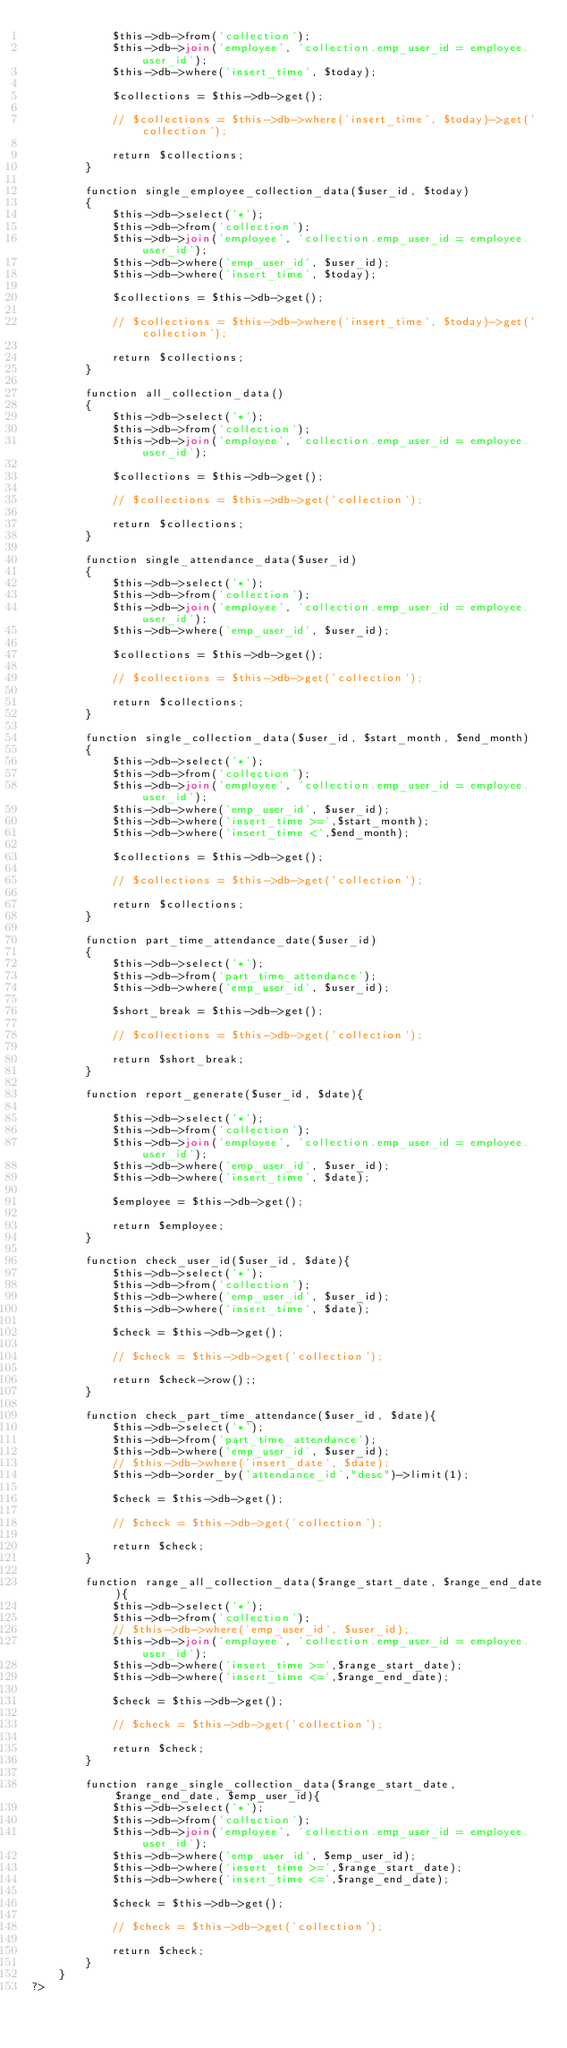<code> <loc_0><loc_0><loc_500><loc_500><_PHP_>			$this->db->from('collection');
			$this->db->join('employee', 'collection.emp_user_id = employee.user_id');
			$this->db->where('insert_time', $today);

			$collections = $this->db->get();

			// $collections = $this->db->where('insert_time', $today)->get('collection');

			return $collections;
		}

		function single_employee_collection_data($user_id, $today)
		{
			$this->db->select('*');
			$this->db->from('collection');
			$this->db->join('employee', 'collection.emp_user_id = employee.user_id');
			$this->db->where('emp_user_id', $user_id);
			$this->db->where('insert_time', $today);

			$collections = $this->db->get();

			// $collections = $this->db->where('insert_time', $today)->get('collection');

			return $collections;
		}

		function all_collection_data()
		{
			$this->db->select('*');
			$this->db->from('collection');
			$this->db->join('employee', 'collection.emp_user_id = employee.user_id');

			$collections = $this->db->get();

			// $collections = $this->db->get('collection');

			return $collections;
		}

		function single_attendance_data($user_id)
		{
			$this->db->select('*');
			$this->db->from('collection');
			$this->db->join('employee', 'collection.emp_user_id = employee.user_id');
			$this->db->where('emp_user_id', $user_id);

			$collections = $this->db->get();

			// $collections = $this->db->get('collection');

			return $collections;
		}

		function single_collection_data($user_id, $start_month, $end_month)
		{
			$this->db->select('*');
			$this->db->from('collection');
			$this->db->join('employee', 'collection.emp_user_id = employee.user_id');
			$this->db->where('emp_user_id', $user_id);
			$this->db->where('insert_time >=',$start_month);
			$this->db->where('insert_time <',$end_month); 

			$collections = $this->db->get();

			// $collections = $this->db->get('collection');

			return $collections;
		}

		function part_time_attendance_date($user_id)
		{
			$this->db->select('*');
			$this->db->from('part_time_attendance');
			$this->db->where('emp_user_id', $user_id);

			$short_break = $this->db->get();

			// $collections = $this->db->get('collection');

			return $short_break;
		}

		function report_generate($user_id, $date){

			$this->db->select('*');
			$this->db->from('collection');
			$this->db->join('employee', 'collection.emp_user_id = employee.user_id');
			$this->db->where('emp_user_id', $user_id);
			$this->db->where('insert_time', $date);

			$employee = $this->db->get();

			return $employee;
		}

		function check_user_id($user_id, $date){
			$this->db->select('*');
			$this->db->from('collection');
			$this->db->where('emp_user_id', $user_id);
			$this->db->where('insert_time', $date);

			$check = $this->db->get();

			// $check = $this->db->get('collection');

			return $check->row();;
		}

		function check_part_time_attendance($user_id, $date){
			$this->db->select('*');
			$this->db->from('part_time_attendance');
			$this->db->where('emp_user_id', $user_id);
			// $this->db->where('insert_date', $date);
			$this->db->order_by('attendance_id',"desc")->limit(1);

			$check = $this->db->get();

			// $check = $this->db->get('collection');

			return $check;
		}

		function range_all_collection_data($range_start_date, $range_end_date){
			$this->db->select('*');
			$this->db->from('collection');
			// $this->db->where('emp_user_id', $user_id);
			$this->db->join('employee', 'collection.emp_user_id = employee.user_id');
			$this->db->where('insert_time >=',$range_start_date);
			$this->db->where('insert_time <=',$range_end_date); 

			$check = $this->db->get();

			// $check = $this->db->get('collection');

			return $check;
		}

		function range_single_collection_data($range_start_date, $range_end_date, $emp_user_id){
			$this->db->select('*');
			$this->db->from('collection');
			$this->db->join('employee', 'collection.emp_user_id = employee.user_id');
			$this->db->where('emp_user_id', $emp_user_id);
			$this->db->where('insert_time >=',$range_start_date);
			$this->db->where('insert_time <=',$range_end_date); 

			$check = $this->db->get();

			// $check = $this->db->get('collection');

			return $check;
		}
	}
?></code> 